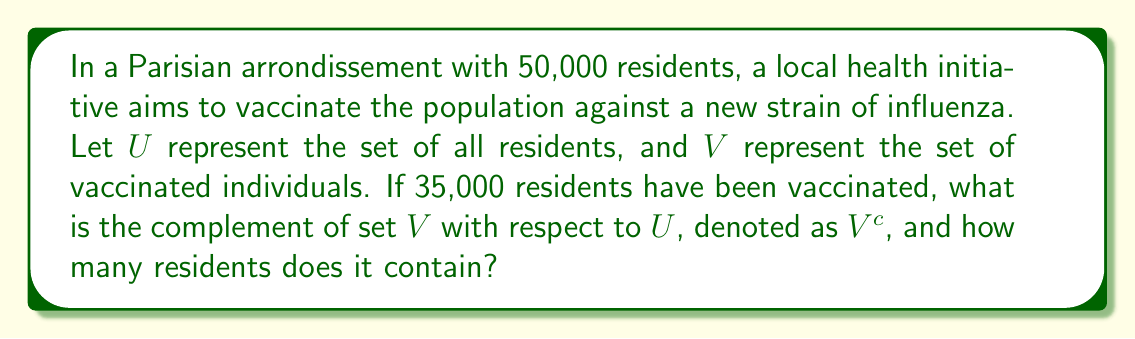Help me with this question. To solve this problem, we need to understand the concept of set complement and apply it to the given scenario:

1) The universal set $U$ represents all residents in the arrondissement:
   $|U| = 50,000$

2) Set $V$ represents vaccinated individuals:
   $|V| = 35,000$

3) The complement of set $V$, denoted as $V^c$, represents all elements in $U$ that are not in $V$. In this case, it's the set of unvaccinated residents.

4) To find $V^c$, we subtract $V$ from $U$:
   $V^c = U - V$

5) The number of elements in $V^c$ is:
   $|V^c| = |U| - |V| = 50,000 - 35,000 = 15,000$

Therefore, $V^c$ represents the set of unvaccinated residents, which contains 15,000 individuals.
Answer: $V^c = \{x \in U : x \notin V\}$, where $|V^c| = 15,000$ 